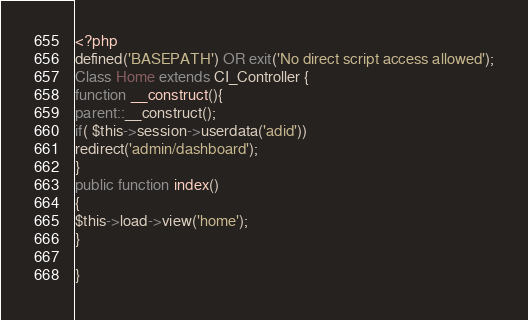<code> <loc_0><loc_0><loc_500><loc_500><_PHP_><?php
defined('BASEPATH') OR exit('No direct script access allowed');
Class Home extends CI_Controller {
function __construct(){
parent::__construct();
if( $this->session->userdata('adid'))
redirect('admin/dashboard');
}
public function index()
{
$this->load->view('home');
}

}	</code> 